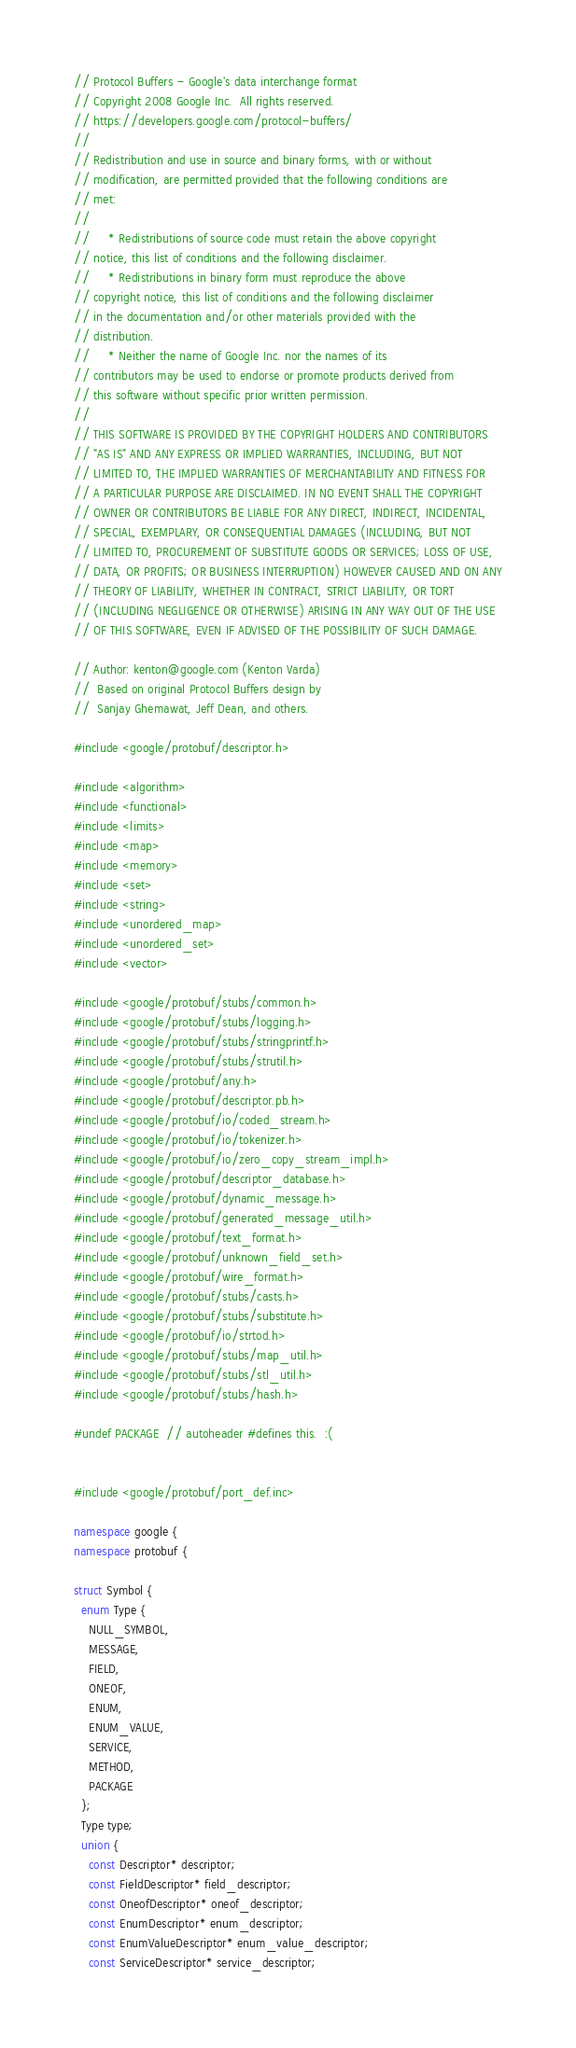Convert code to text. <code><loc_0><loc_0><loc_500><loc_500><_C++_>// Protocol Buffers - Google's data interchange format
// Copyright 2008 Google Inc.  All rights reserved.
// https://developers.google.com/protocol-buffers/
//
// Redistribution and use in source and binary forms, with or without
// modification, are permitted provided that the following conditions are
// met:
//
//     * Redistributions of source code must retain the above copyright
// notice, this list of conditions and the following disclaimer.
//     * Redistributions in binary form must reproduce the above
// copyright notice, this list of conditions and the following disclaimer
// in the documentation and/or other materials provided with the
// distribution.
//     * Neither the name of Google Inc. nor the names of its
// contributors may be used to endorse or promote products derived from
// this software without specific prior written permission.
//
// THIS SOFTWARE IS PROVIDED BY THE COPYRIGHT HOLDERS AND CONTRIBUTORS
// "AS IS" AND ANY EXPRESS OR IMPLIED WARRANTIES, INCLUDING, BUT NOT
// LIMITED TO, THE IMPLIED WARRANTIES OF MERCHANTABILITY AND FITNESS FOR
// A PARTICULAR PURPOSE ARE DISCLAIMED. IN NO EVENT SHALL THE COPYRIGHT
// OWNER OR CONTRIBUTORS BE LIABLE FOR ANY DIRECT, INDIRECT, INCIDENTAL,
// SPECIAL, EXEMPLARY, OR CONSEQUENTIAL DAMAGES (INCLUDING, BUT NOT
// LIMITED TO, PROCUREMENT OF SUBSTITUTE GOODS OR SERVICES; LOSS OF USE,
// DATA, OR PROFITS; OR BUSINESS INTERRUPTION) HOWEVER CAUSED AND ON ANY
// THEORY OF LIABILITY, WHETHER IN CONTRACT, STRICT LIABILITY, OR TORT
// (INCLUDING NEGLIGENCE OR OTHERWISE) ARISING IN ANY WAY OUT OF THE USE
// OF THIS SOFTWARE, EVEN IF ADVISED OF THE POSSIBILITY OF SUCH DAMAGE.

// Author: kenton@google.com (Kenton Varda)
//  Based on original Protocol Buffers design by
//  Sanjay Ghemawat, Jeff Dean, and others.

#include <google/protobuf/descriptor.h>

#include <algorithm>
#include <functional>
#include <limits>
#include <map>
#include <memory>
#include <set>
#include <string>
#include <unordered_map>
#include <unordered_set>
#include <vector>

#include <google/protobuf/stubs/common.h>
#include <google/protobuf/stubs/logging.h>
#include <google/protobuf/stubs/stringprintf.h>
#include <google/protobuf/stubs/strutil.h>
#include <google/protobuf/any.h>
#include <google/protobuf/descriptor.pb.h>
#include <google/protobuf/io/coded_stream.h>
#include <google/protobuf/io/tokenizer.h>
#include <google/protobuf/io/zero_copy_stream_impl.h>
#include <google/protobuf/descriptor_database.h>
#include <google/protobuf/dynamic_message.h>
#include <google/protobuf/generated_message_util.h>
#include <google/protobuf/text_format.h>
#include <google/protobuf/unknown_field_set.h>
#include <google/protobuf/wire_format.h>
#include <google/protobuf/stubs/casts.h>
#include <google/protobuf/stubs/substitute.h>
#include <google/protobuf/io/strtod.h>
#include <google/protobuf/stubs/map_util.h>
#include <google/protobuf/stubs/stl_util.h>
#include <google/protobuf/stubs/hash.h>

#undef PACKAGE  // autoheader #defines this.  :(


#include <google/protobuf/port_def.inc>

namespace google {
namespace protobuf {

struct Symbol {
  enum Type {
    NULL_SYMBOL,
    MESSAGE,
    FIELD,
    ONEOF,
    ENUM,
    ENUM_VALUE,
    SERVICE,
    METHOD,
    PACKAGE
  };
  Type type;
  union {
    const Descriptor* descriptor;
    const FieldDescriptor* field_descriptor;
    const OneofDescriptor* oneof_descriptor;
    const EnumDescriptor* enum_descriptor;
    const EnumValueDescriptor* enum_value_descriptor;
    const ServiceDescriptor* service_descriptor;</code> 